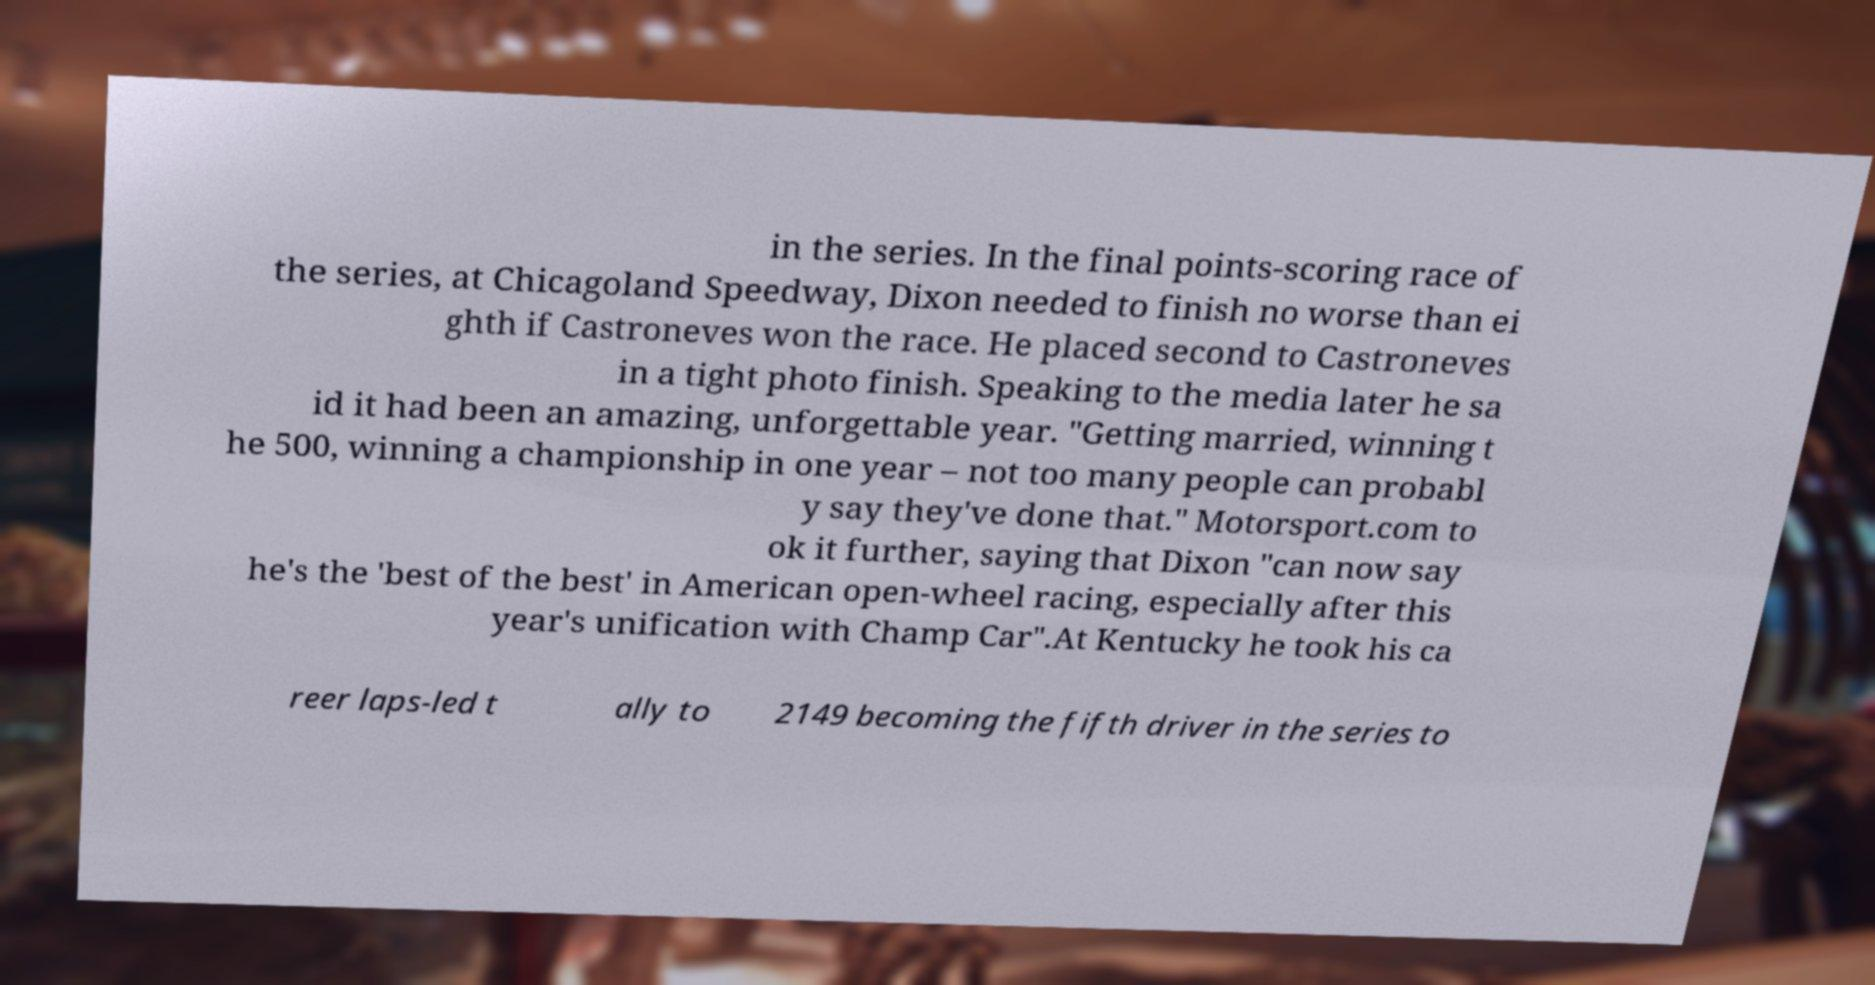There's text embedded in this image that I need extracted. Can you transcribe it verbatim? in the series. In the final points-scoring race of the series, at Chicagoland Speedway, Dixon needed to finish no worse than ei ghth if Castroneves won the race. He placed second to Castroneves in a tight photo finish. Speaking to the media later he sa id it had been an amazing, unforgettable year. "Getting married, winning t he 500, winning a championship in one year – not too many people can probabl y say they've done that." Motorsport.com to ok it further, saying that Dixon "can now say he's the 'best of the best' in American open-wheel racing, especially after this year's unification with Champ Car".At Kentucky he took his ca reer laps-led t ally to 2149 becoming the fifth driver in the series to 